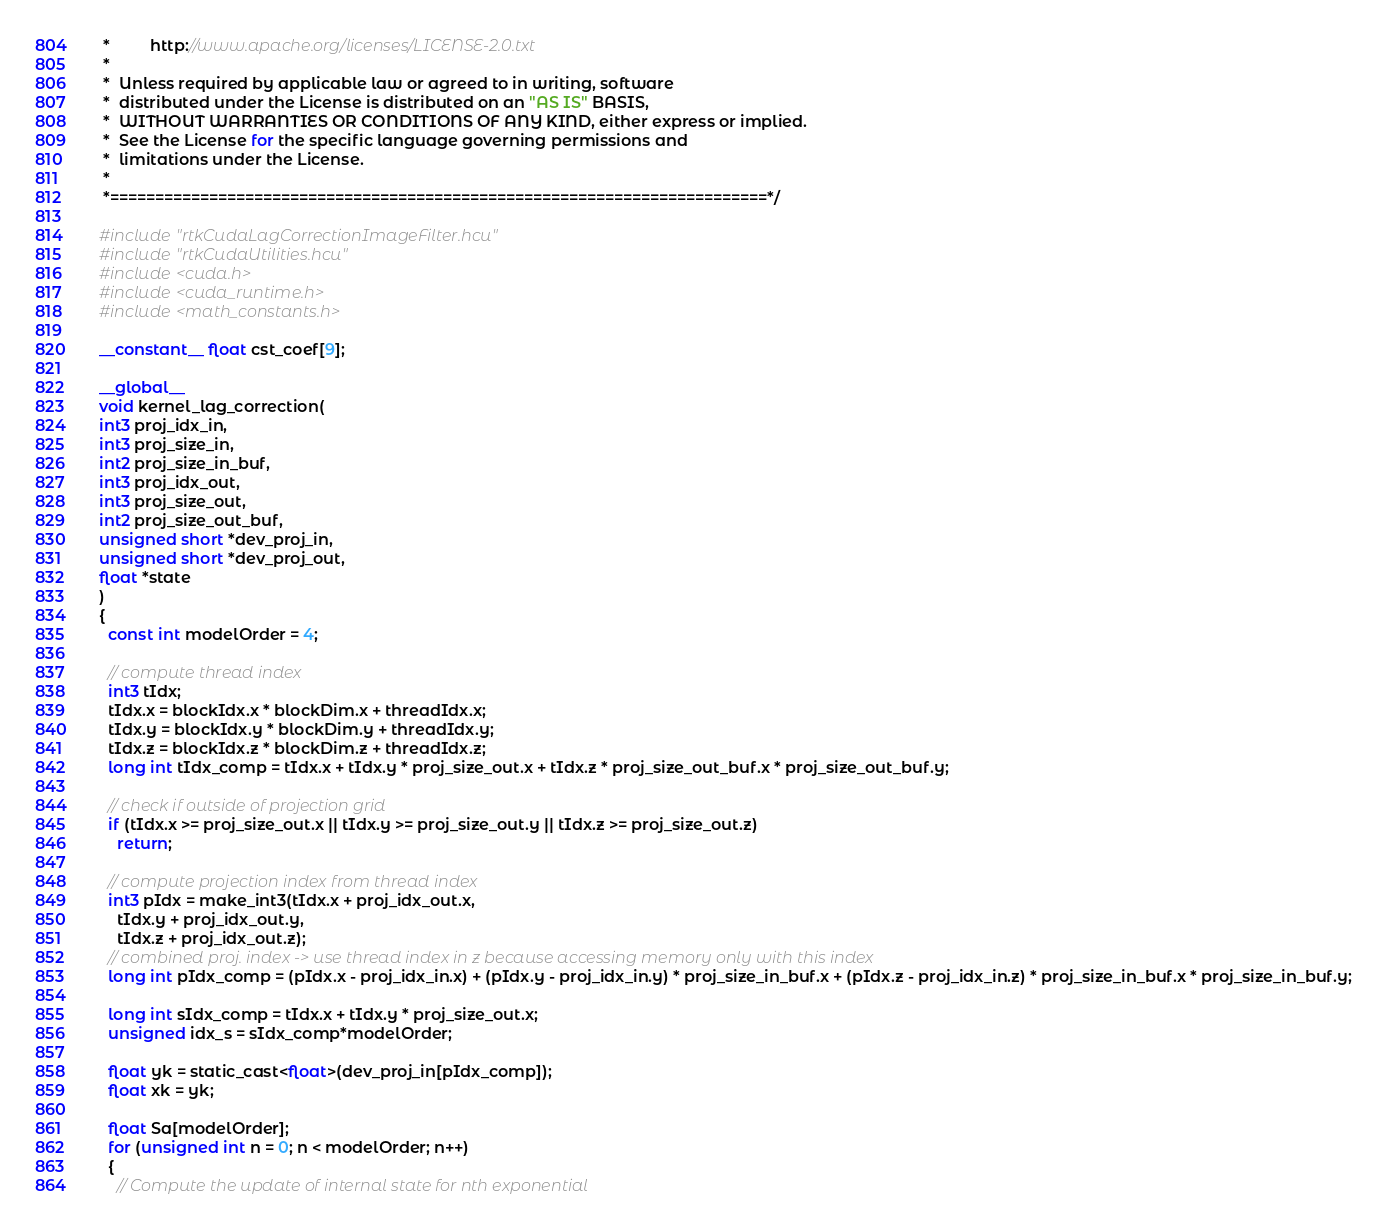<code> <loc_0><loc_0><loc_500><loc_500><_Cuda_> *         http://www.apache.org/licenses/LICENSE-2.0.txt
 *
 *  Unless required by applicable law or agreed to in writing, software
 *  distributed under the License is distributed on an "AS IS" BASIS,
 *  WITHOUT WARRANTIES OR CONDITIONS OF ANY KIND, either express or implied.
 *  See the License for the specific language governing permissions and
 *  limitations under the License.
 *
 *=========================================================================*/

#include "rtkCudaLagCorrectionImageFilter.hcu"
#include "rtkCudaUtilities.hcu"
#include <cuda.h>
#include <cuda_runtime.h>
#include <math_constants.h>

__constant__ float cst_coef[9];

__global__
void kernel_lag_correction(
int3 proj_idx_in,
int3 proj_size_in,
int2 proj_size_in_buf,
int3 proj_idx_out,
int3 proj_size_out,
int2 proj_size_out_buf,
unsigned short *dev_proj_in,
unsigned short *dev_proj_out,
float *state
)
{
  const int modelOrder = 4;

  // compute thread index
  int3 tIdx;
  tIdx.x = blockIdx.x * blockDim.x + threadIdx.x;
  tIdx.y = blockIdx.y * blockDim.y + threadIdx.y;
  tIdx.z = blockIdx.z * blockDim.z + threadIdx.z;
  long int tIdx_comp = tIdx.x + tIdx.y * proj_size_out.x + tIdx.z * proj_size_out_buf.x * proj_size_out_buf.y;

  // check if outside of projection grid
  if (tIdx.x >= proj_size_out.x || tIdx.y >= proj_size_out.y || tIdx.z >= proj_size_out.z)
    return;

  // compute projection index from thread index
  int3 pIdx = make_int3(tIdx.x + proj_idx_out.x,
    tIdx.y + proj_idx_out.y,
    tIdx.z + proj_idx_out.z);
  // combined proj. index -> use thread index in z because accessing memory only with this index
  long int pIdx_comp = (pIdx.x - proj_idx_in.x) + (pIdx.y - proj_idx_in.y) * proj_size_in_buf.x + (pIdx.z - proj_idx_in.z) * proj_size_in_buf.x * proj_size_in_buf.y;
  
  long int sIdx_comp = tIdx.x + tIdx.y * proj_size_out.x;
  unsigned idx_s = sIdx_comp*modelOrder;
  
  float yk = static_cast<float>(dev_proj_in[pIdx_comp]);
  float xk = yk;
  
  float Sa[modelOrder];
  for (unsigned int n = 0; n < modelOrder; n++)
  {
    // Compute the update of internal state for nth exponential</code> 